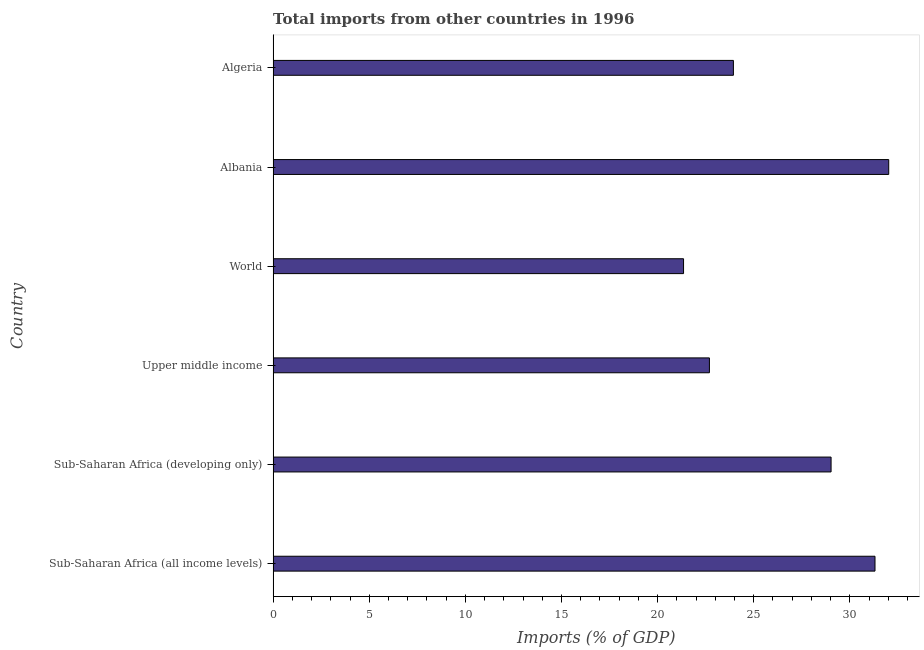Does the graph contain grids?
Offer a terse response. No. What is the title of the graph?
Offer a very short reply. Total imports from other countries in 1996. What is the label or title of the X-axis?
Offer a very short reply. Imports (% of GDP). What is the total imports in World?
Your response must be concise. 21.35. Across all countries, what is the maximum total imports?
Offer a terse response. 32.02. Across all countries, what is the minimum total imports?
Make the answer very short. 21.35. In which country was the total imports maximum?
Make the answer very short. Albania. In which country was the total imports minimum?
Ensure brevity in your answer.  World. What is the sum of the total imports?
Give a very brief answer. 160.35. What is the difference between the total imports in Albania and World?
Offer a very short reply. 10.67. What is the average total imports per country?
Make the answer very short. 26.73. What is the median total imports?
Offer a very short reply. 26.49. What is the ratio of the total imports in Sub-Saharan Africa (all income levels) to that in Upper middle income?
Provide a short and direct response. 1.38. Is the total imports in Sub-Saharan Africa (all income levels) less than that in Upper middle income?
Offer a terse response. No. Is the difference between the total imports in Albania and Algeria greater than the difference between any two countries?
Offer a very short reply. No. What is the difference between the highest and the second highest total imports?
Your answer should be compact. 0.71. Is the sum of the total imports in Sub-Saharan Africa (developing only) and Upper middle income greater than the maximum total imports across all countries?
Make the answer very short. Yes. What is the difference between the highest and the lowest total imports?
Offer a terse response. 10.67. How many bars are there?
Your answer should be compact. 6. How many countries are there in the graph?
Ensure brevity in your answer.  6. What is the difference between two consecutive major ticks on the X-axis?
Your response must be concise. 5. What is the Imports (% of GDP) of Sub-Saharan Africa (all income levels)?
Ensure brevity in your answer.  31.31. What is the Imports (% of GDP) of Sub-Saharan Africa (developing only)?
Your answer should be compact. 29.03. What is the Imports (% of GDP) of Upper middle income?
Offer a terse response. 22.7. What is the Imports (% of GDP) of World?
Provide a short and direct response. 21.35. What is the Imports (% of GDP) of Albania?
Your answer should be very brief. 32.02. What is the Imports (% of GDP) in Algeria?
Provide a short and direct response. 23.94. What is the difference between the Imports (% of GDP) in Sub-Saharan Africa (all income levels) and Sub-Saharan Africa (developing only)?
Keep it short and to the point. 2.29. What is the difference between the Imports (% of GDP) in Sub-Saharan Africa (all income levels) and Upper middle income?
Keep it short and to the point. 8.61. What is the difference between the Imports (% of GDP) in Sub-Saharan Africa (all income levels) and World?
Keep it short and to the point. 9.96. What is the difference between the Imports (% of GDP) in Sub-Saharan Africa (all income levels) and Albania?
Offer a terse response. -0.71. What is the difference between the Imports (% of GDP) in Sub-Saharan Africa (all income levels) and Algeria?
Make the answer very short. 7.37. What is the difference between the Imports (% of GDP) in Sub-Saharan Africa (developing only) and Upper middle income?
Provide a succinct answer. 6.33. What is the difference between the Imports (% of GDP) in Sub-Saharan Africa (developing only) and World?
Your answer should be very brief. 7.67. What is the difference between the Imports (% of GDP) in Sub-Saharan Africa (developing only) and Albania?
Keep it short and to the point. -3. What is the difference between the Imports (% of GDP) in Sub-Saharan Africa (developing only) and Algeria?
Provide a short and direct response. 5.08. What is the difference between the Imports (% of GDP) in Upper middle income and World?
Your answer should be compact. 1.35. What is the difference between the Imports (% of GDP) in Upper middle income and Albania?
Ensure brevity in your answer.  -9.33. What is the difference between the Imports (% of GDP) in Upper middle income and Algeria?
Ensure brevity in your answer.  -1.25. What is the difference between the Imports (% of GDP) in World and Albania?
Your answer should be very brief. -10.67. What is the difference between the Imports (% of GDP) in World and Algeria?
Give a very brief answer. -2.59. What is the difference between the Imports (% of GDP) in Albania and Algeria?
Your response must be concise. 8.08. What is the ratio of the Imports (% of GDP) in Sub-Saharan Africa (all income levels) to that in Sub-Saharan Africa (developing only)?
Your answer should be compact. 1.08. What is the ratio of the Imports (% of GDP) in Sub-Saharan Africa (all income levels) to that in Upper middle income?
Offer a terse response. 1.38. What is the ratio of the Imports (% of GDP) in Sub-Saharan Africa (all income levels) to that in World?
Your answer should be very brief. 1.47. What is the ratio of the Imports (% of GDP) in Sub-Saharan Africa (all income levels) to that in Albania?
Offer a very short reply. 0.98. What is the ratio of the Imports (% of GDP) in Sub-Saharan Africa (all income levels) to that in Algeria?
Provide a succinct answer. 1.31. What is the ratio of the Imports (% of GDP) in Sub-Saharan Africa (developing only) to that in Upper middle income?
Your answer should be very brief. 1.28. What is the ratio of the Imports (% of GDP) in Sub-Saharan Africa (developing only) to that in World?
Provide a succinct answer. 1.36. What is the ratio of the Imports (% of GDP) in Sub-Saharan Africa (developing only) to that in Albania?
Provide a succinct answer. 0.91. What is the ratio of the Imports (% of GDP) in Sub-Saharan Africa (developing only) to that in Algeria?
Your answer should be compact. 1.21. What is the ratio of the Imports (% of GDP) in Upper middle income to that in World?
Ensure brevity in your answer.  1.06. What is the ratio of the Imports (% of GDP) in Upper middle income to that in Albania?
Your answer should be very brief. 0.71. What is the ratio of the Imports (% of GDP) in Upper middle income to that in Algeria?
Your answer should be compact. 0.95. What is the ratio of the Imports (% of GDP) in World to that in Albania?
Keep it short and to the point. 0.67. What is the ratio of the Imports (% of GDP) in World to that in Algeria?
Give a very brief answer. 0.89. What is the ratio of the Imports (% of GDP) in Albania to that in Algeria?
Your answer should be very brief. 1.34. 